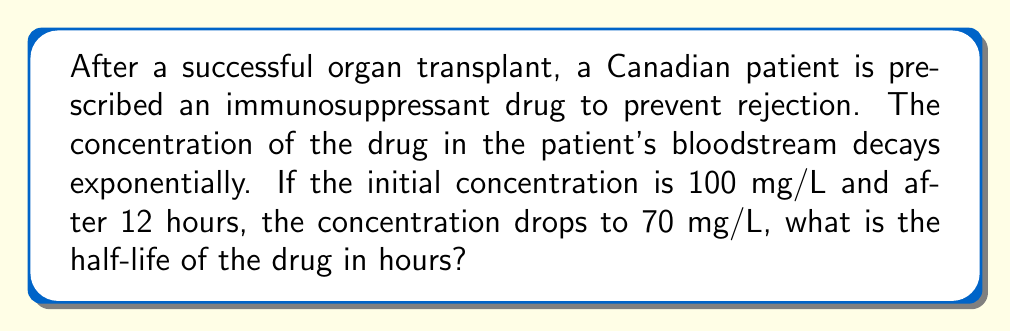Could you help me with this problem? Let's approach this step-by-step using the exponential decay formula:

1) The general form of exponential decay is:
   $$A(t) = A_0 \cdot e^{-kt}$$
   where $A(t)$ is the amount at time $t$, $A_0$ is the initial amount, $k$ is the decay constant, and $t$ is time.

2) We know:
   $A_0 = 100$ mg/L
   $A(12) = 70$ mg/L
   $t = 12$ hours

3) Substituting these values into the formula:
   $$70 = 100 \cdot e^{-12k}$$

4) Dividing both sides by 100:
   $$0.7 = e^{-12k}$$

5) Taking the natural log of both sides:
   $$\ln(0.7) = -12k$$

6) Solving for $k$:
   $$k = -\frac{\ln(0.7)}{12} \approx 0.0297$$

7) The half-life $t_{1/2}$ is related to $k$ by:
   $$t_{1/2} = \frac{\ln(2)}{k}$$

8) Substituting our value for $k$:
   $$t_{1/2} = \frac{\ln(2)}{0.0297} \approx 23.34$$ hours

Therefore, the half-life of the immunosuppressant drug is approximately 23.34 hours.
Answer: 23.34 hours 